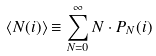Convert formula to latex. <formula><loc_0><loc_0><loc_500><loc_500>\langle N ( i ) \rangle \equiv \sum _ { N = 0 } ^ { \infty } N \cdot P _ { N } ( i )</formula> 